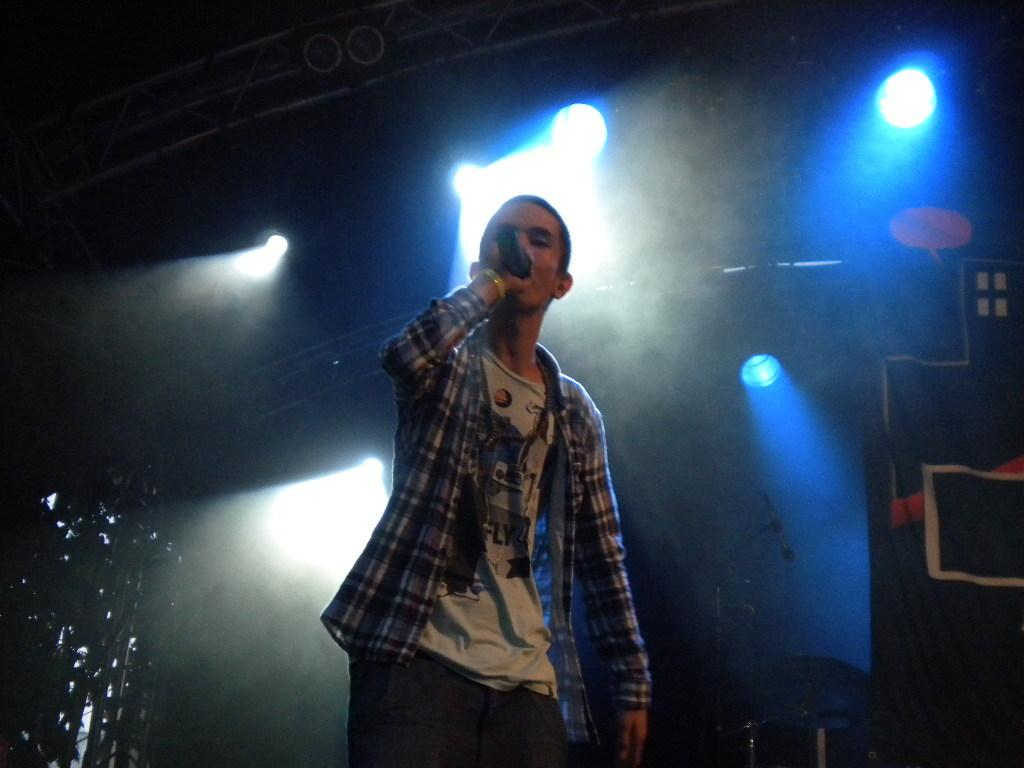What is the main subject of the image? There is a boy in the image. What is the boy doing in the image? The boy is standing and singing a song. What object is the boy holding in the image? The boy is holding a microphone. What can be seen in the background of the image? There are lights visible in the background of the image, and the background appears to be dark. What type of pencil is the boy using to draw in the image? There is no pencil present in the image; the boy is holding a microphone and singing a song. 